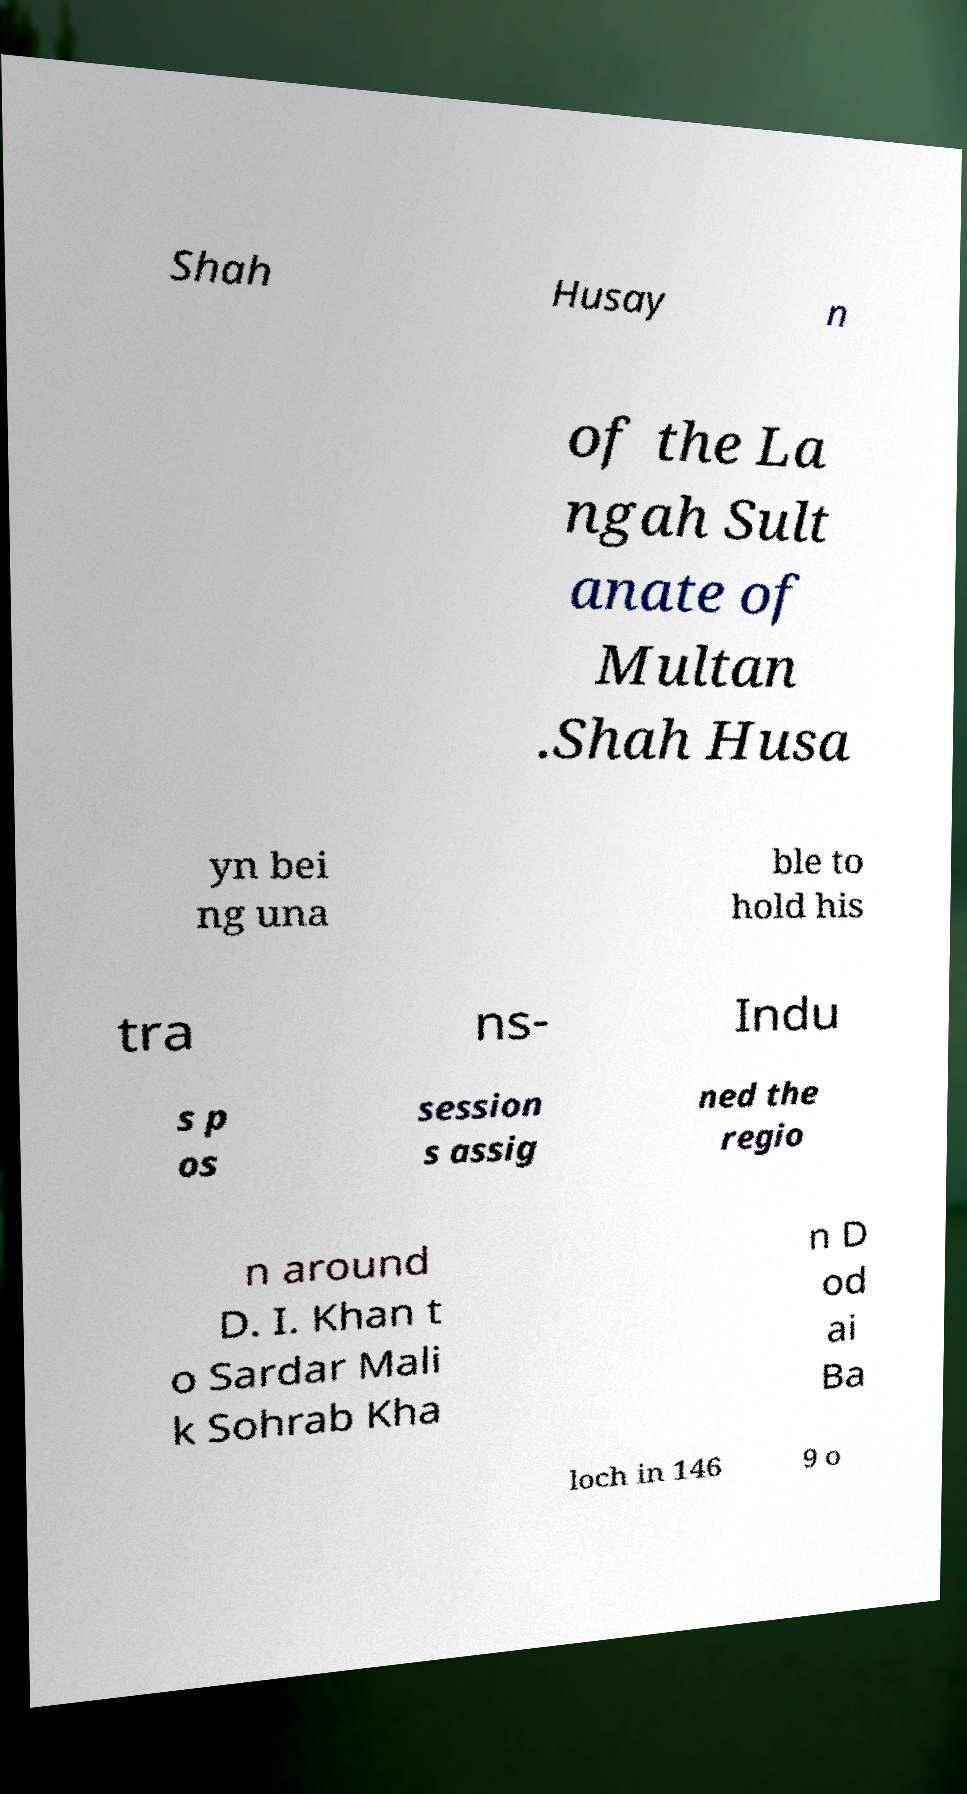Could you extract and type out the text from this image? Shah Husay n of the La ngah Sult anate of Multan .Shah Husa yn bei ng una ble to hold his tra ns- Indu s p os session s assig ned the regio n around D. I. Khan t o Sardar Mali k Sohrab Kha n D od ai Ba loch in 146 9 o 